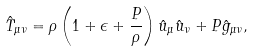<formula> <loc_0><loc_0><loc_500><loc_500>\hat { T } _ { \mu \nu } = \rho \left ( 1 + \epsilon + \frac { P } { \rho } \right ) \hat { u } _ { \mu } \hat { u } _ { \nu } + P \hat { g } _ { \mu \nu } ,</formula> 